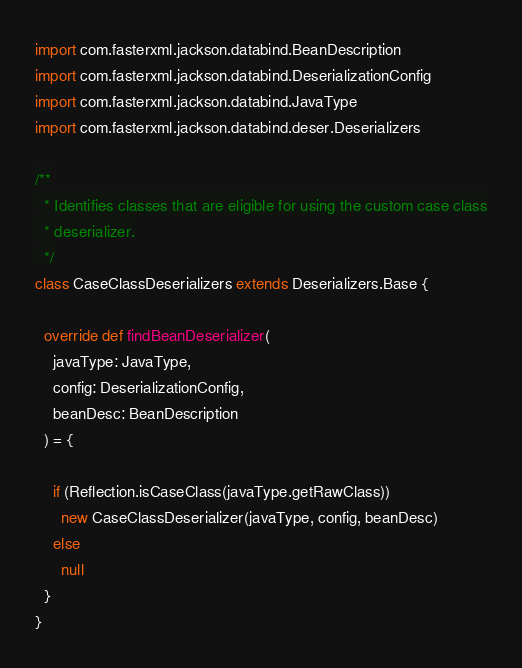Convert code to text. <code><loc_0><loc_0><loc_500><loc_500><_Scala_>import com.fasterxml.jackson.databind.BeanDescription
import com.fasterxml.jackson.databind.DeserializationConfig
import com.fasterxml.jackson.databind.JavaType
import com.fasterxml.jackson.databind.deser.Deserializers

/**
  * Identifies classes that are eligible for using the custom case class
  * deserializer.
  */
class CaseClassDeserializers extends Deserializers.Base {

  override def findBeanDeserializer(
    javaType: JavaType,
    config: DeserializationConfig,
    beanDesc: BeanDescription
  ) = {

    if (Reflection.isCaseClass(javaType.getRawClass))
      new CaseClassDeserializer(javaType, config, beanDesc)
    else
      null
  }
}
</code> 